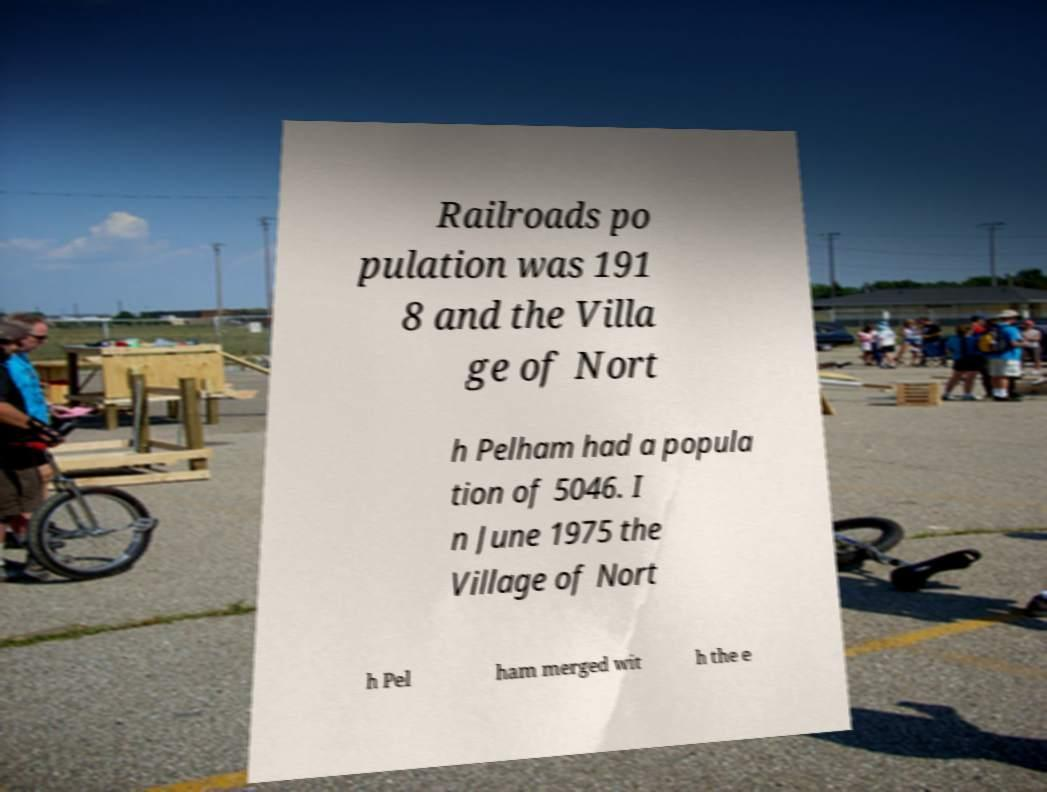Can you accurately transcribe the text from the provided image for me? Railroads po pulation was 191 8 and the Villa ge of Nort h Pelham had a popula tion of 5046. I n June 1975 the Village of Nort h Pel ham merged wit h the e 